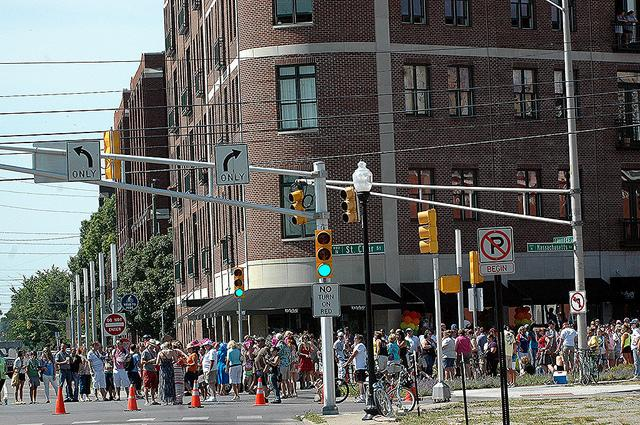Why are the traffic cones positioned in the location that they are? Please explain your reasoning. road closure. There are many pedestrians beyond the road. for so many people to congregate in the middle of the road it would likely be for an arranged event where the road would be closed and need to be marked off as such. 